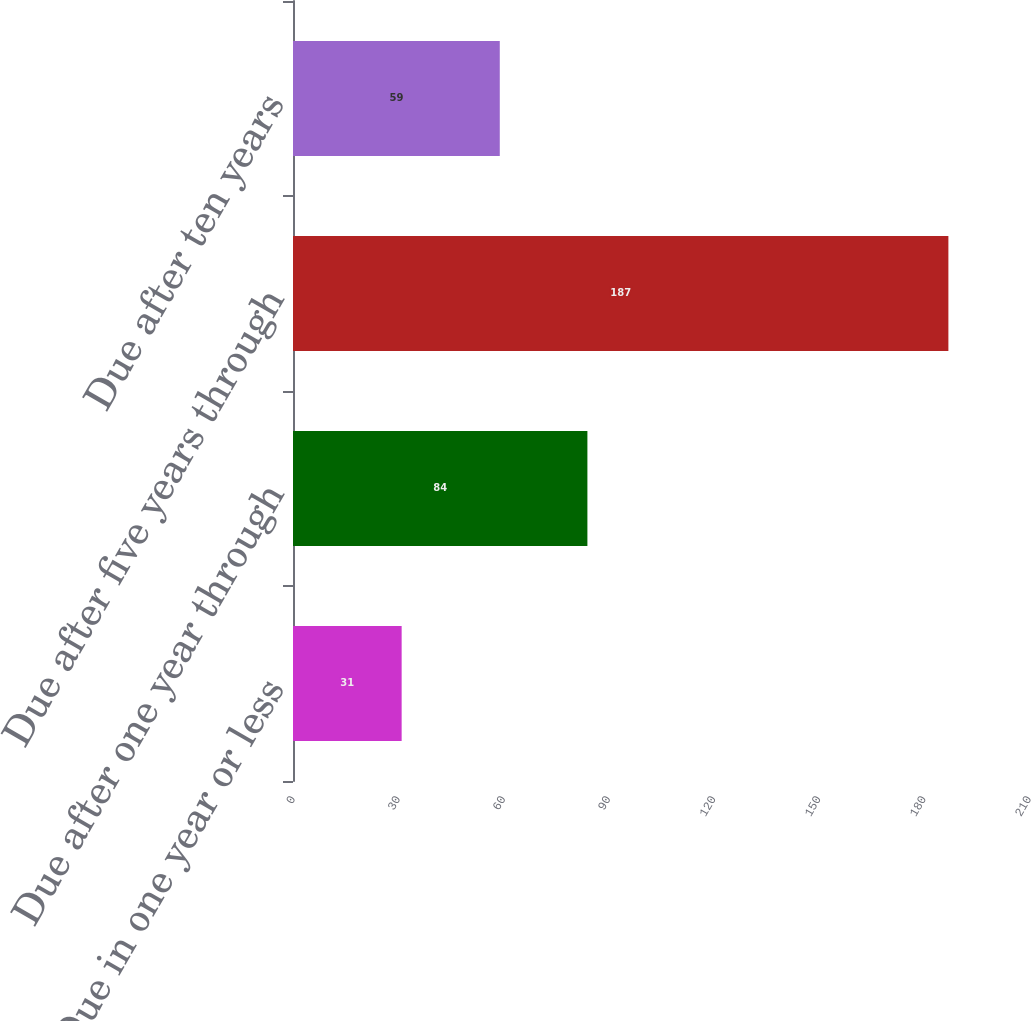Convert chart. <chart><loc_0><loc_0><loc_500><loc_500><bar_chart><fcel>Due in one year or less<fcel>Due after one year through<fcel>Due after five years through<fcel>Due after ten years<nl><fcel>31<fcel>84<fcel>187<fcel>59<nl></chart> 